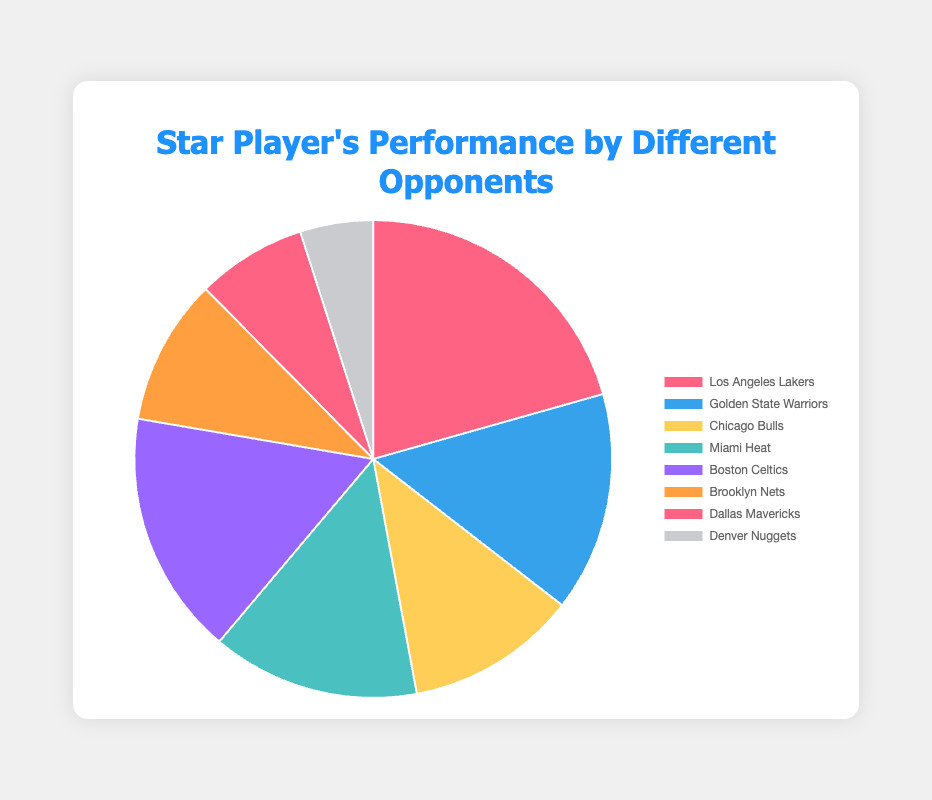Which opponent did the star player score the most points against? The pie chart shows different opponents and their corresponding percentages of points scored by the star player. The largest slice represents the Los Angeles Lakers with 20.8%. This indicates that the star player scored the most points against them.
Answer: Los Angeles Lakers Which opponent did the star player score the least points against? The smallest slice in the pie chart corresponds to the Denver Nuggets with 5.0%. This indicates that the star player scored the fewest points against them.
Answer: Denver Nuggets What is the total percentage of points scored by the star player against the Golden State Warriors and the Miami Heat? From the pie chart, the percentages for the Golden State Warriors and Miami Heat are 15.0% and 14.2% respectively. Adding them together, we get 15.0% + 14.2% = 29.2%.
Answer: 29.2% How much more percentage did the star player score against the Boston Celtics compared to the Chicago Bulls? The star player scored 16.7% against the Boston Celtics and 11.7% against the Chicago Bulls. Subtracting these values, we get 16.7% - 11.7% = 5.0%.
Answer: 5.0% What is the combined percentage of points scored by the star player against the Los Angeles Lakers, Chicago Bulls, and Brooklyn Nets? Adding the percentages for these three opponents: Los Angeles Lakers (20.8%), Chicago Bulls (11.7%), and Brooklyn Nets (10.0%), we get 20.8% + 11.7% + 10.0% = 42.5%.
Answer: 42.5% Which opponent has a light blue colored slice in the pie chart? Observing the color legend in the pie chart, the light blue colored slice corresponds to the Golden State Warriors.
Answer: Golden State Warriors How many opponents did the star player score over 15% against? Looking at the pie chart, the star player scored over 15% against Los Angeles Lakers (20.8%) and Boston Celtics (16.7%). That makes two opponents.
Answer: 2 